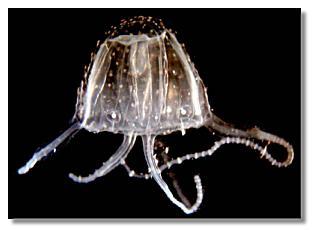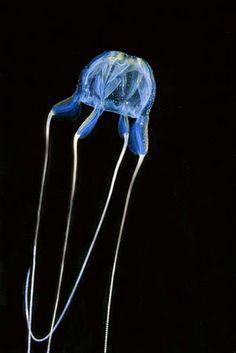The first image is the image on the left, the second image is the image on the right. For the images displayed, is the sentence "The jellyfish on the right is blue and has four tentacles." factually correct? Answer yes or no. Yes. 